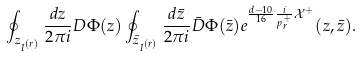<formula> <loc_0><loc_0><loc_500><loc_500>\oint _ { z _ { I ^ { ( r ) } } } \frac { d z } { 2 \pi i } D \Phi ( z ) \oint _ { \bar { z } _ { I ^ { ( r ) } } } \frac { d \bar { z } } { 2 \pi i } \bar { D } \Phi ( \bar { z } ) e ^ { \frac { d - 1 0 } { 1 6 } \frac { i } { p ^ { + } _ { r } } \mathcal { X } ^ { + } } ( z , \bar { z } ) .</formula> 